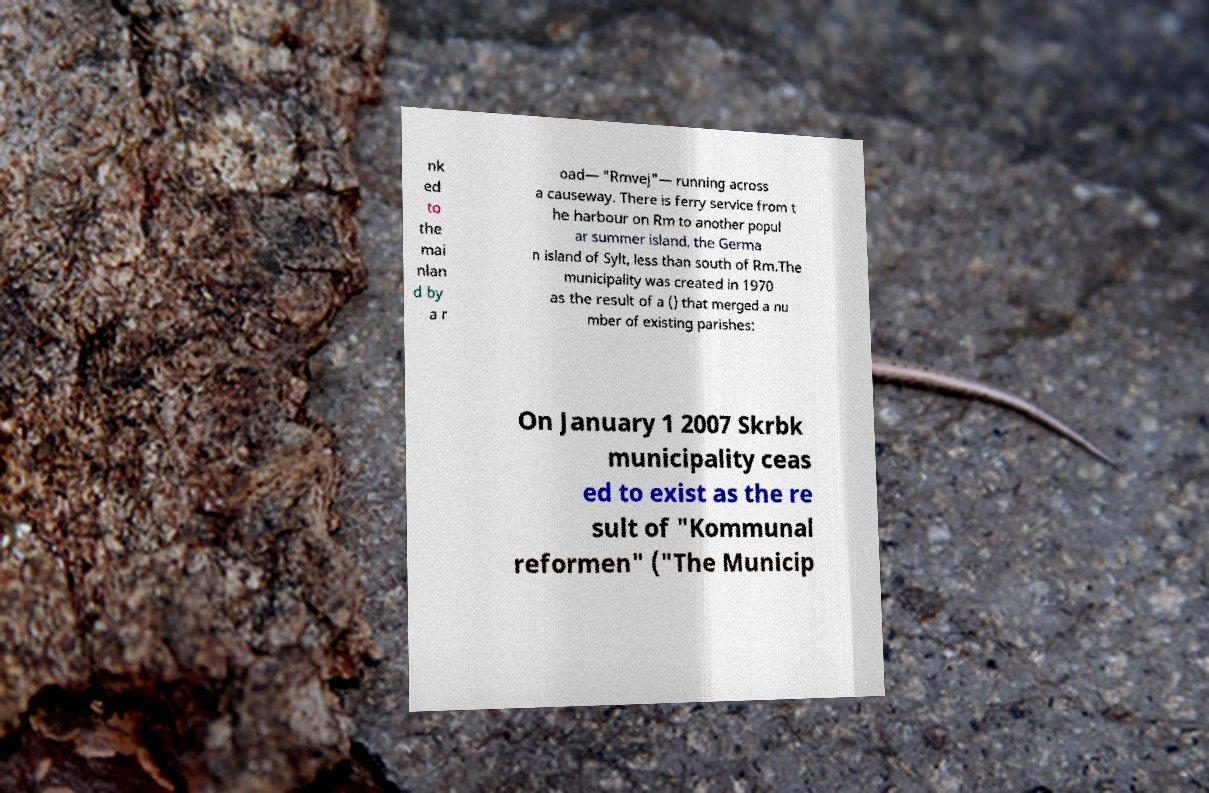For documentation purposes, I need the text within this image transcribed. Could you provide that? nk ed to the mai nlan d by a r oad— "Rmvej"— running across a causeway. There is ferry service from t he harbour on Rm to another popul ar summer island, the Germa n island of Sylt, less than south of Rm.The municipality was created in 1970 as the result of a () that merged a nu mber of existing parishes: On January 1 2007 Skrbk municipality ceas ed to exist as the re sult of "Kommunal reformen" ("The Municip 